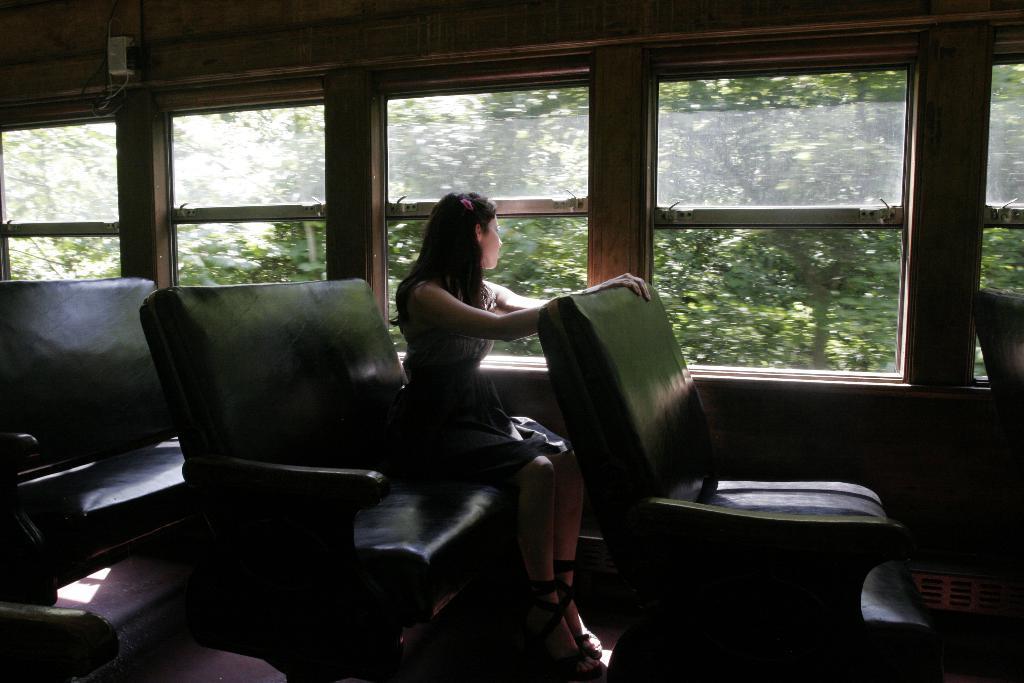Could you give a brief overview of what you see in this image? In the middle of the image a woman is sitting on a chair in the vehicle and there are some glass windows. Through the glass windows we can see some trees. 